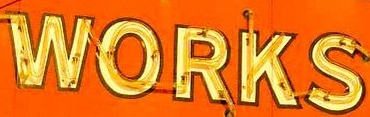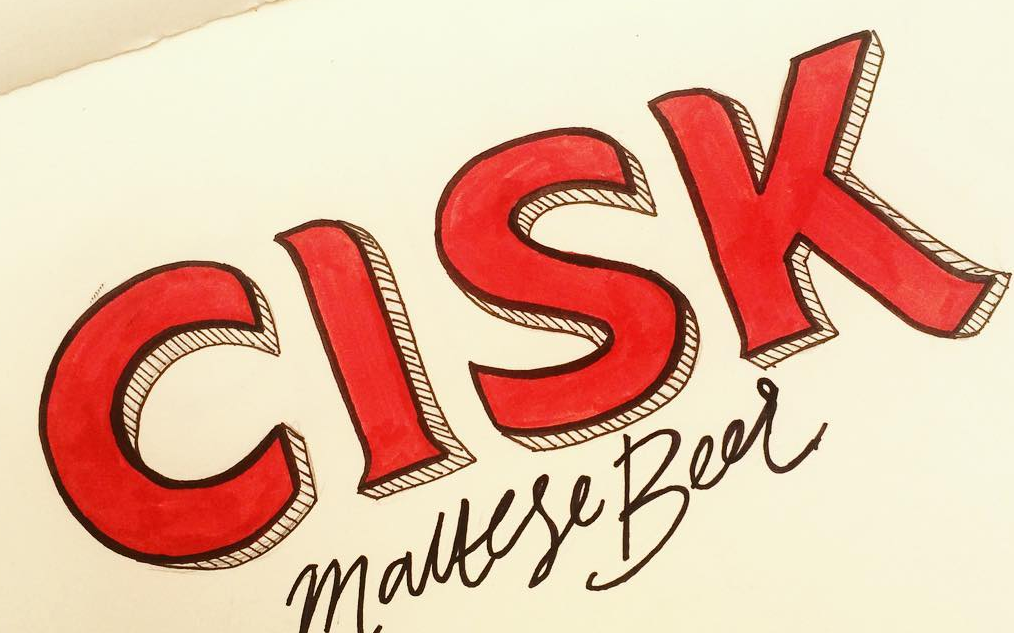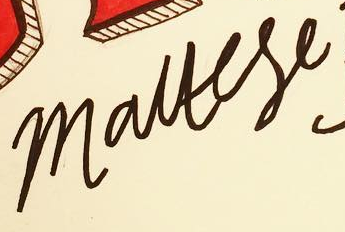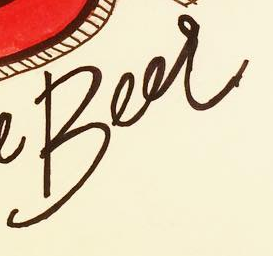Read the text from these images in sequence, separated by a semicolon. WORKS; CISK; mauese; Beer 